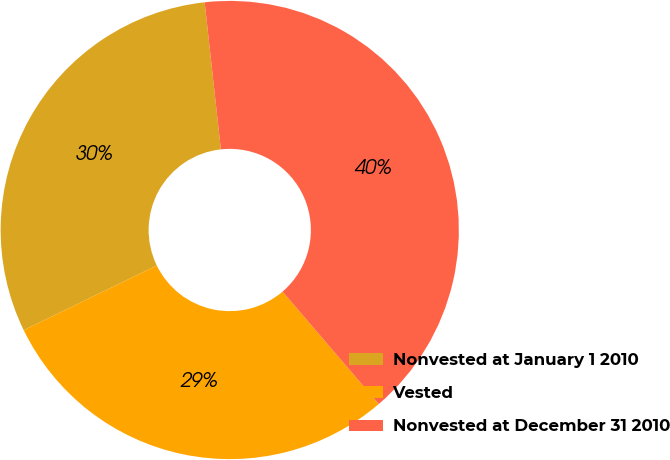Convert chart to OTSL. <chart><loc_0><loc_0><loc_500><loc_500><pie_chart><fcel>Nonvested at January 1 2010<fcel>Vested<fcel>Nonvested at December 31 2010<nl><fcel>30.45%<fcel>29.07%<fcel>40.47%<nl></chart> 